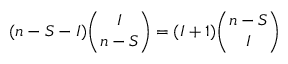Convert formula to latex. <formula><loc_0><loc_0><loc_500><loc_500>( n - S - I ) \binom { I } { n - S } = ( I + 1 ) \binom { n - S } { I }</formula> 